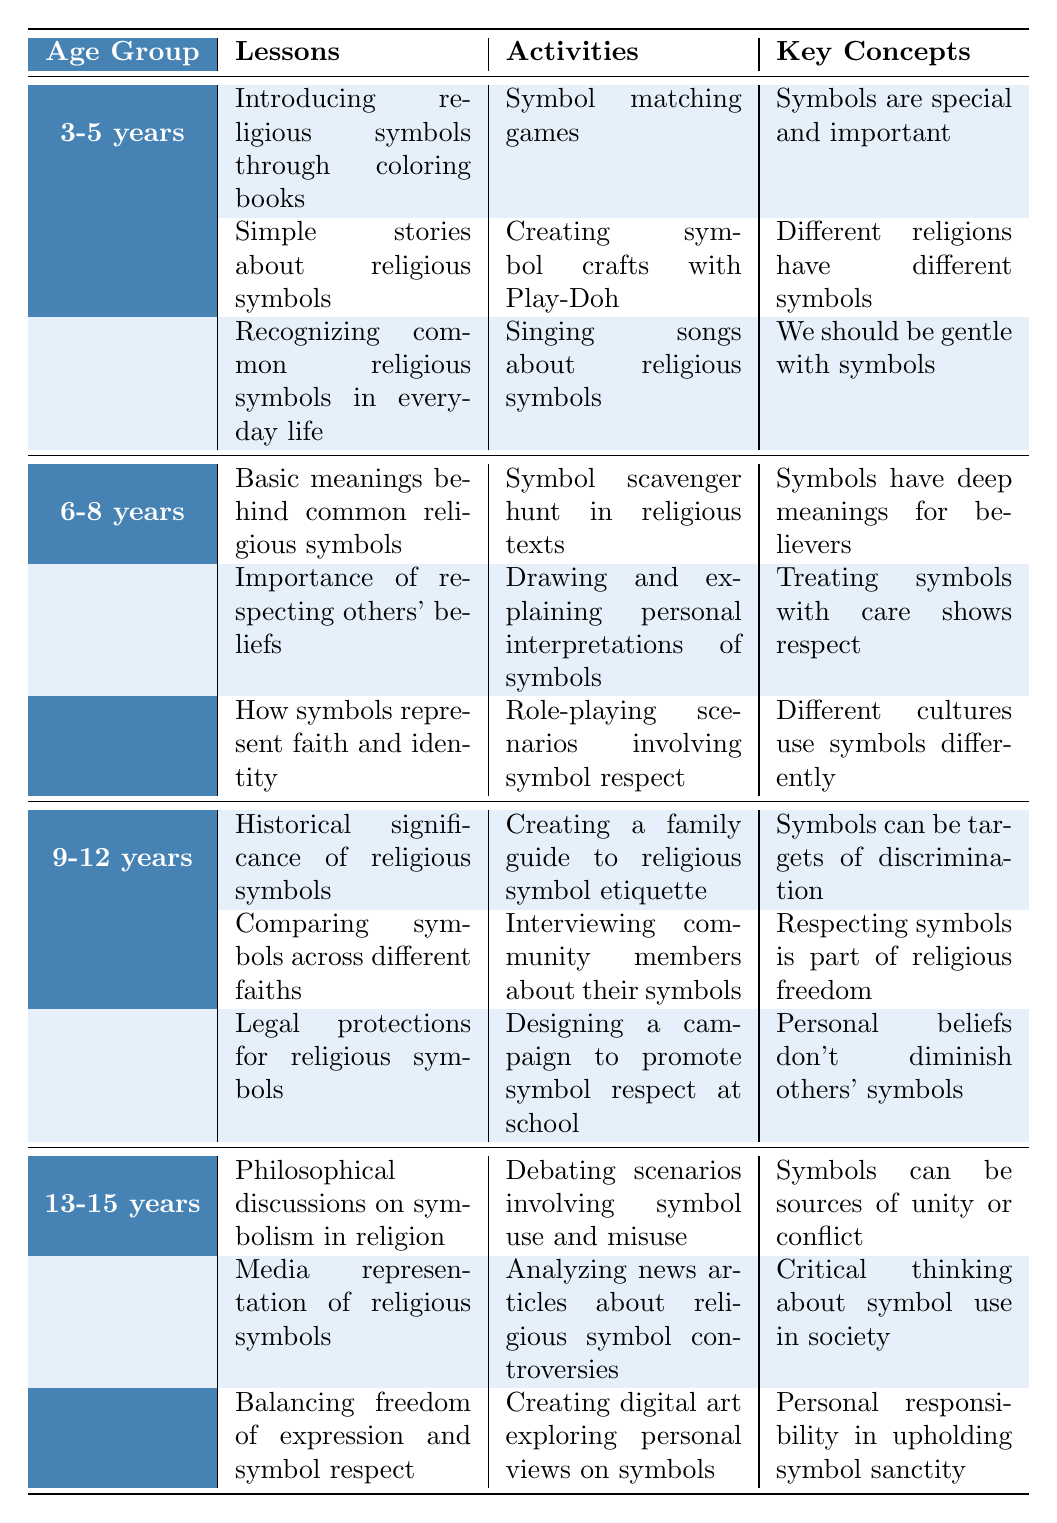What activities are suggested for children aged 6-8 years? The table lists several activities under the age group of 6-8 years, including "Symbol scavenger hunt in religious texts," "Drawing and explaining personal interpretations of symbols," and "Role-playing scenarios involving symbol respect."
Answer: Symbol scavenger hunt, drawing personal interpretations, role-playing scenarios What are the key concepts for the age group 9-12 years? According to the table, the key concepts for children aged 9-12 years include "Symbols can be targets of discrimination," "Respecting symbols is part of religious freedom," and "Personal beliefs don't diminish others' symbols."
Answer: Targets of discrimination, respect as freedom, personal beliefs don't diminish Are there any lessons related to the importance of respecting others' beliefs? Yes, the table shows that for the age group 6-8 years, one of the lessons is "Importance of respecting others' beliefs."
Answer: Yes What is the difference in activities between 3-5 years and 13-15 years age groups? The activities for 3-5 years include symbol matching games and creating crafts, while for 13-15 years, activities involve debating scenarios and analyzing news articles, indicating a shift from play-focused to critical thinking-based activities.
Answer: Shift from play to critical thinking How many lessons are provided for each age group? By counting the lessons listed for each age group: 3-5 years has 3 lessons, 6-8 years has 3 lessons, 9-12 years has 3 lessons, and 13-15 years has 3 lessons, which totals to 12 lessons across all age groups.
Answer: 3 lessons each group, totaling 12 Which age group includes lessons about the historical significance of religious symbols? The table specifies that children aged 9-12 years have a lesson titled "Historical significance of religious symbols."
Answer: 9-12 years What are the common symbols associated with Islam listed in the table? The table presents the common symbols associated with Islam as "Crescent and Star," "Name of Allah in Arabic," and "Mosque."
Answer: Crescent and Star, Name of Allah, Mosque How do the lessons for 13-15 years promote critical thinking about symbols? The lessons for 13-15 years involve philosophical discussions on symbolism, media representation of symbols, and balancing freedom of expression with respect, encouraging students to analyze and discuss complex ideas about symbols critically.
Answer: Promote analysis of complex ideas on symbols Which key concept emphasizes the responsibility of individuals regarding symbols in the 13-15 age group? The key concept "Personal responsibility in upholding symbol sanctity" directly emphasizes the individual's duty concerning symbols for the 13-15 age group.
Answer: Personal responsibility in upholding sanctity What are some challenges parents might face when teaching about religious symbols? The table outlines several challenges, including addressing symbol misuse in media, helping children navigate peer pressure, and explaining complex historical contexts of symbols.
Answer: Addressing misuse, peer pressure, explaining history 